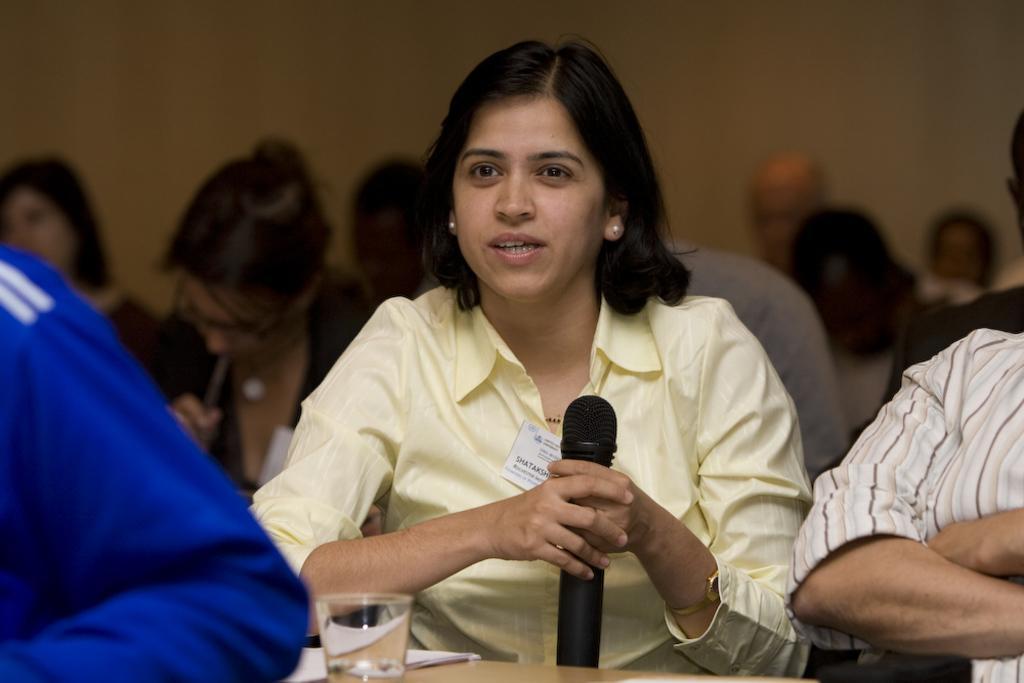Can you describe this image briefly? In this image women who is wearing a yellow shirt and holding a black mic. In front of her there is a water glass on a table. On the right, there is a woman who is wearing a linen shirt. On the left there is a person who is wearing a blue jacket. There is woman who is holding a pen in his mouth. On the they are some peoples who are in blue. 